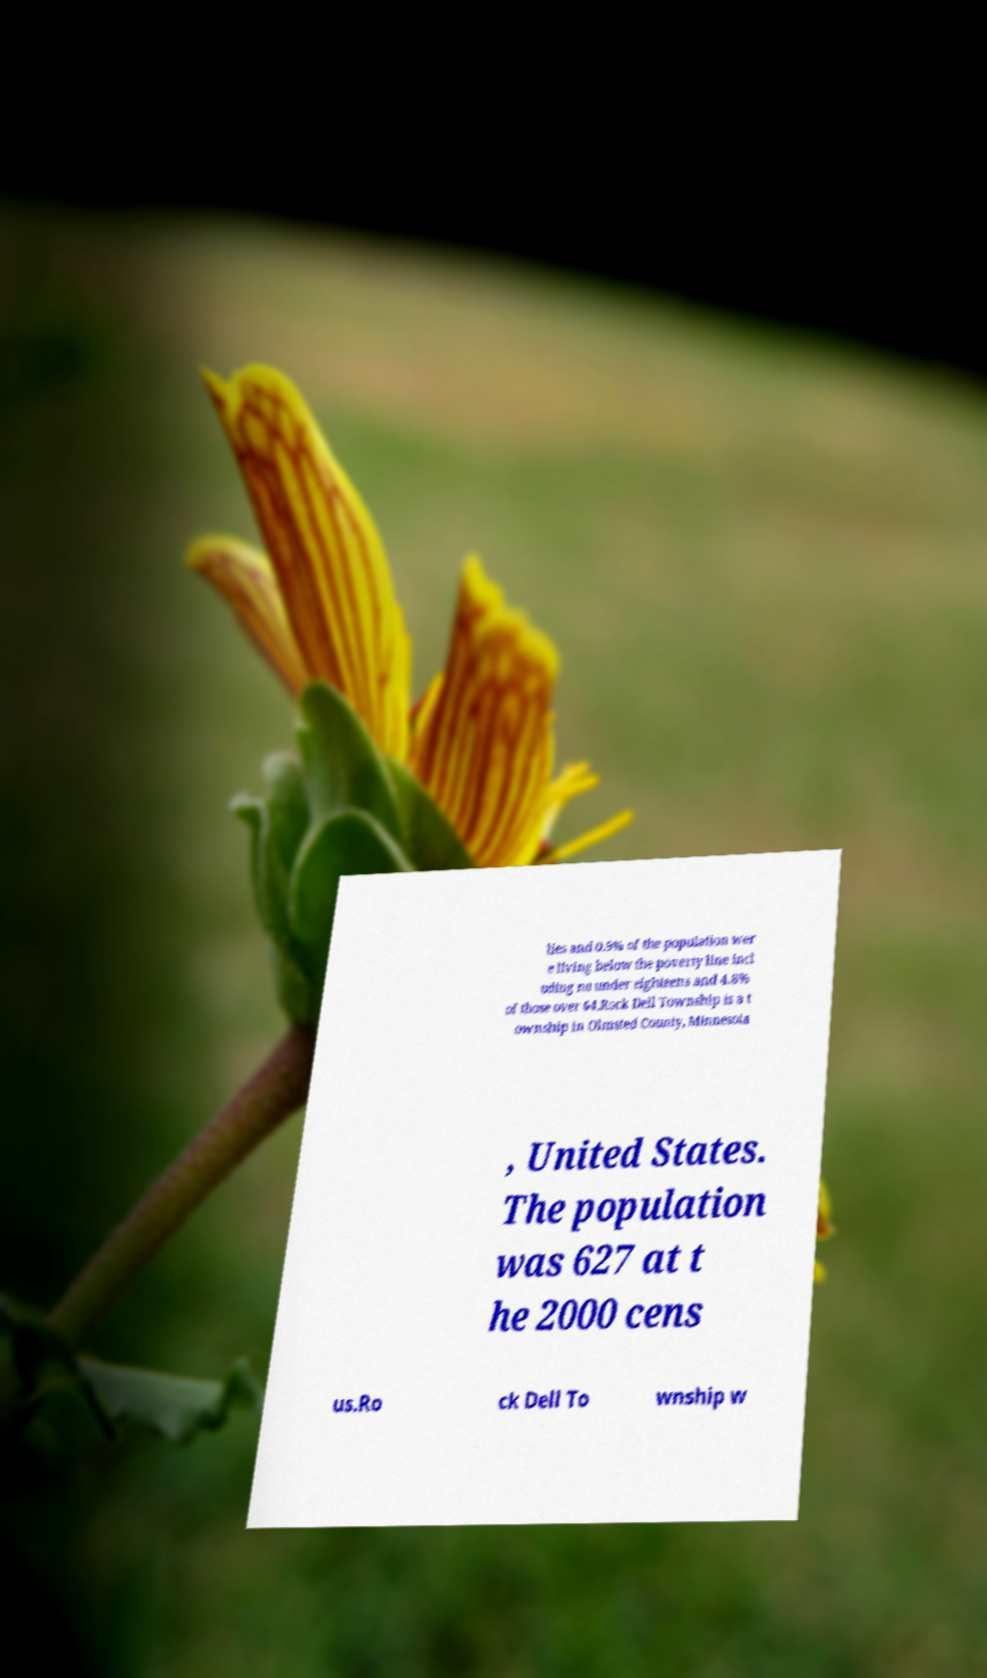Can you read and provide the text displayed in the image?This photo seems to have some interesting text. Can you extract and type it out for me? lies and 0.9% of the population wer e living below the poverty line incl uding no under eighteens and 4.8% of those over 64.Rock Dell Township is a t ownship in Olmsted County, Minnesota , United States. The population was 627 at t he 2000 cens us.Ro ck Dell To wnship w 